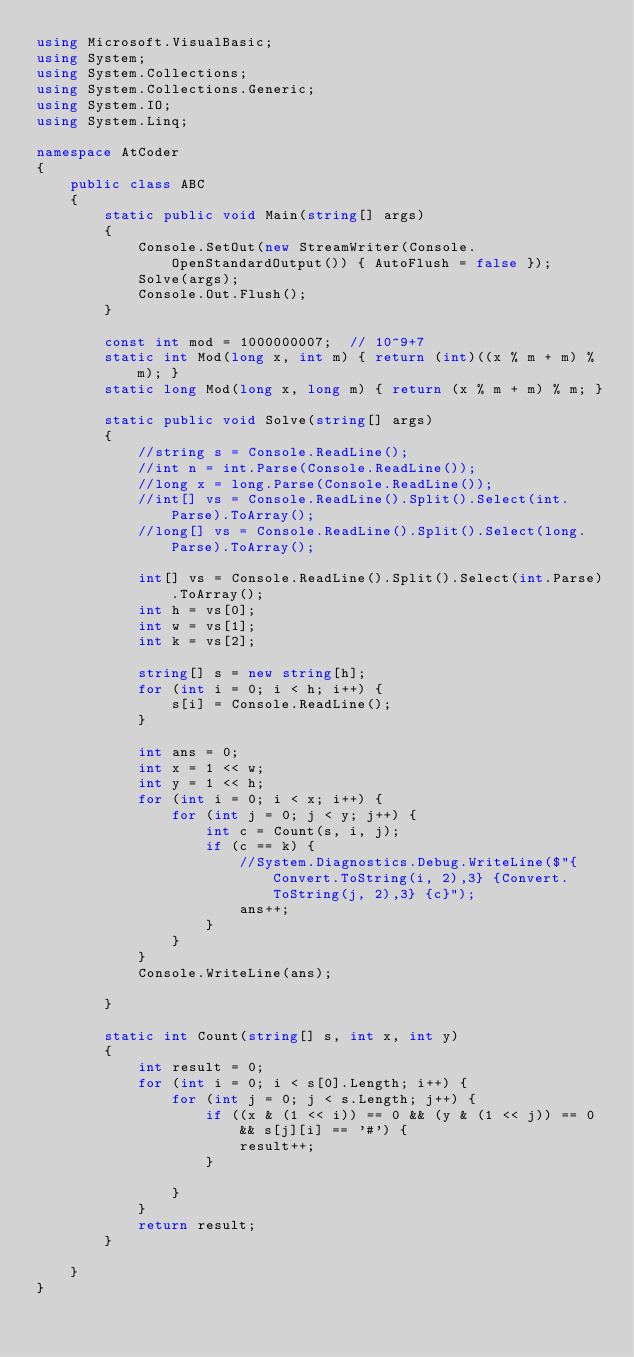<code> <loc_0><loc_0><loc_500><loc_500><_C#_>using Microsoft.VisualBasic;
using System;
using System.Collections;
using System.Collections.Generic;
using System.IO;
using System.Linq;

namespace AtCoder
{
	public class ABC
	{
		static public void Main(string[] args)
		{
			Console.SetOut(new StreamWriter(Console.OpenStandardOutput()) { AutoFlush = false });
			Solve(args);
			Console.Out.Flush();
		}

		const int mod = 1000000007;  // 10^9+7
		static int Mod(long x, int m) { return (int)((x % m + m) % m); }
		static long Mod(long x, long m) { return (x % m + m) % m; }

		static public void Solve(string[] args)
		{
			//string s = Console.ReadLine();
			//int n = int.Parse(Console.ReadLine());
			//long x = long.Parse(Console.ReadLine());
			//int[] vs = Console.ReadLine().Split().Select(int.Parse).ToArray();
			//long[] vs = Console.ReadLine().Split().Select(long.Parse).ToArray();

			int[] vs = Console.ReadLine().Split().Select(int.Parse).ToArray();
			int h = vs[0];
			int w = vs[1];
			int k = vs[2];

			string[] s = new string[h];
			for (int i = 0; i < h; i++) {
				s[i] = Console.ReadLine();
			}

			int ans = 0;
			int x = 1 << w;
			int y = 1 << h;
			for (int i = 0; i < x; i++) {
				for (int j = 0; j < y; j++) {
					int c = Count(s, i, j);
					if (c == k) {
						//System.Diagnostics.Debug.WriteLine($"{Convert.ToString(i, 2),3} {Convert.ToString(j, 2),3} {c}");
						ans++;
					}
				}
			}
			Console.WriteLine(ans);

		}

		static int Count(string[] s, int x, int y)
		{
			int result = 0;
			for (int i = 0; i < s[0].Length; i++) {
				for (int j = 0; j < s.Length; j++) {
					if ((x & (1 << i)) == 0 && (y & (1 << j)) == 0 && s[j][i] == '#') {
						result++;
					}

				}
			}
			return result;
		}

	}
}
</code> 